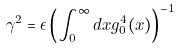Convert formula to latex. <formula><loc_0><loc_0><loc_500><loc_500>\gamma ^ { 2 } = \epsilon \left ( \int _ { 0 } ^ { \infty } d x g _ { 0 } ^ { 4 } ( x ) \right ) ^ { - 1 }</formula> 